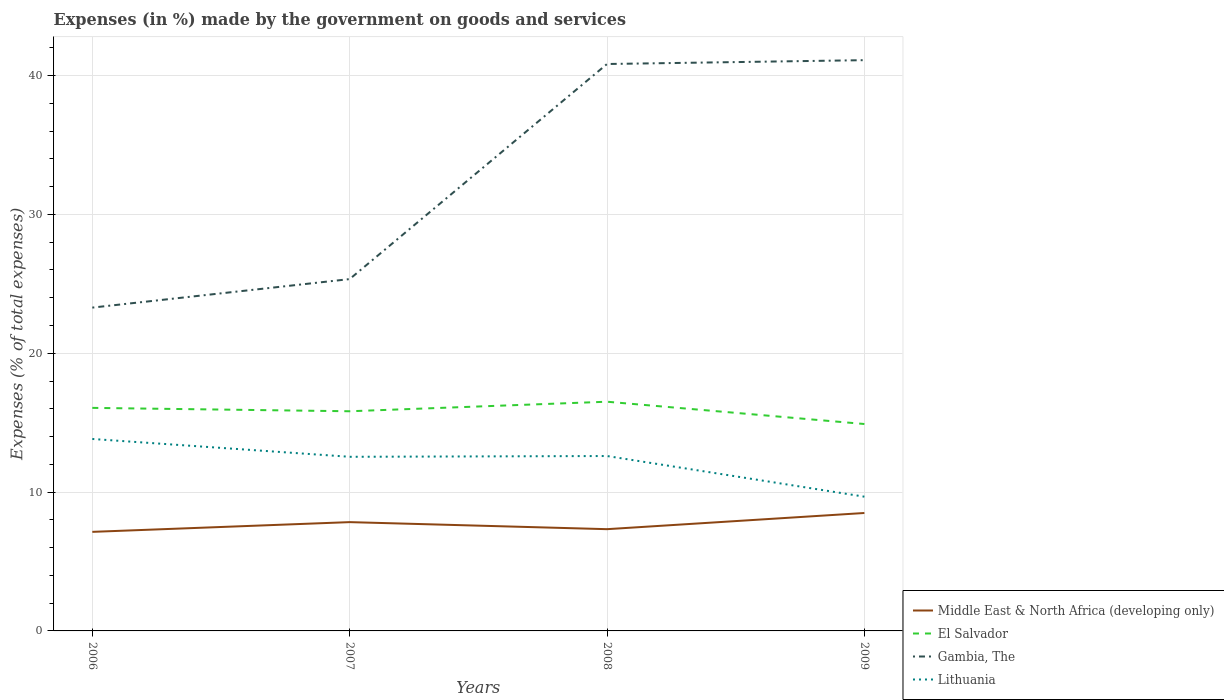How many different coloured lines are there?
Make the answer very short. 4. Is the number of lines equal to the number of legend labels?
Provide a succinct answer. Yes. Across all years, what is the maximum percentage of expenses made by the government on goods and services in Gambia, The?
Keep it short and to the point. 23.29. In which year was the percentage of expenses made by the government on goods and services in Middle East & North Africa (developing only) maximum?
Your answer should be compact. 2006. What is the total percentage of expenses made by the government on goods and services in El Salvador in the graph?
Provide a short and direct response. -0.44. What is the difference between the highest and the second highest percentage of expenses made by the government on goods and services in El Salvador?
Ensure brevity in your answer.  1.61. Is the percentage of expenses made by the government on goods and services in Gambia, The strictly greater than the percentage of expenses made by the government on goods and services in El Salvador over the years?
Provide a succinct answer. No. How many lines are there?
Your response must be concise. 4. How many years are there in the graph?
Your answer should be compact. 4. Are the values on the major ticks of Y-axis written in scientific E-notation?
Offer a very short reply. No. What is the title of the graph?
Your answer should be very brief. Expenses (in %) made by the government on goods and services. Does "High income: nonOECD" appear as one of the legend labels in the graph?
Your answer should be very brief. No. What is the label or title of the X-axis?
Give a very brief answer. Years. What is the label or title of the Y-axis?
Make the answer very short. Expenses (% of total expenses). What is the Expenses (% of total expenses) in Middle East & North Africa (developing only) in 2006?
Keep it short and to the point. 7.13. What is the Expenses (% of total expenses) in El Salvador in 2006?
Make the answer very short. 16.07. What is the Expenses (% of total expenses) in Gambia, The in 2006?
Offer a very short reply. 23.29. What is the Expenses (% of total expenses) in Lithuania in 2006?
Ensure brevity in your answer.  13.83. What is the Expenses (% of total expenses) of Middle East & North Africa (developing only) in 2007?
Provide a succinct answer. 7.84. What is the Expenses (% of total expenses) in El Salvador in 2007?
Offer a terse response. 15.82. What is the Expenses (% of total expenses) in Gambia, The in 2007?
Your answer should be very brief. 25.34. What is the Expenses (% of total expenses) of Lithuania in 2007?
Your answer should be compact. 12.54. What is the Expenses (% of total expenses) of Middle East & North Africa (developing only) in 2008?
Keep it short and to the point. 7.33. What is the Expenses (% of total expenses) in El Salvador in 2008?
Provide a short and direct response. 16.51. What is the Expenses (% of total expenses) of Gambia, The in 2008?
Your response must be concise. 40.83. What is the Expenses (% of total expenses) of Lithuania in 2008?
Provide a short and direct response. 12.6. What is the Expenses (% of total expenses) in Middle East & North Africa (developing only) in 2009?
Provide a succinct answer. 8.49. What is the Expenses (% of total expenses) of El Salvador in 2009?
Your answer should be very brief. 14.9. What is the Expenses (% of total expenses) in Gambia, The in 2009?
Provide a succinct answer. 41.11. What is the Expenses (% of total expenses) in Lithuania in 2009?
Your answer should be very brief. 9.67. Across all years, what is the maximum Expenses (% of total expenses) of Middle East & North Africa (developing only)?
Your answer should be very brief. 8.49. Across all years, what is the maximum Expenses (% of total expenses) of El Salvador?
Offer a very short reply. 16.51. Across all years, what is the maximum Expenses (% of total expenses) in Gambia, The?
Your answer should be very brief. 41.11. Across all years, what is the maximum Expenses (% of total expenses) of Lithuania?
Provide a short and direct response. 13.83. Across all years, what is the minimum Expenses (% of total expenses) in Middle East & North Africa (developing only)?
Offer a terse response. 7.13. Across all years, what is the minimum Expenses (% of total expenses) of El Salvador?
Provide a short and direct response. 14.9. Across all years, what is the minimum Expenses (% of total expenses) in Gambia, The?
Your answer should be compact. 23.29. Across all years, what is the minimum Expenses (% of total expenses) of Lithuania?
Give a very brief answer. 9.67. What is the total Expenses (% of total expenses) in Middle East & North Africa (developing only) in the graph?
Your answer should be compact. 30.79. What is the total Expenses (% of total expenses) in El Salvador in the graph?
Make the answer very short. 63.3. What is the total Expenses (% of total expenses) in Gambia, The in the graph?
Provide a short and direct response. 130.57. What is the total Expenses (% of total expenses) in Lithuania in the graph?
Provide a short and direct response. 48.63. What is the difference between the Expenses (% of total expenses) of Middle East & North Africa (developing only) in 2006 and that in 2007?
Give a very brief answer. -0.7. What is the difference between the Expenses (% of total expenses) of El Salvador in 2006 and that in 2007?
Make the answer very short. 0.24. What is the difference between the Expenses (% of total expenses) in Gambia, The in 2006 and that in 2007?
Provide a short and direct response. -2.05. What is the difference between the Expenses (% of total expenses) in Lithuania in 2006 and that in 2007?
Offer a very short reply. 1.28. What is the difference between the Expenses (% of total expenses) of Middle East & North Africa (developing only) in 2006 and that in 2008?
Provide a short and direct response. -0.19. What is the difference between the Expenses (% of total expenses) in El Salvador in 2006 and that in 2008?
Keep it short and to the point. -0.44. What is the difference between the Expenses (% of total expenses) of Gambia, The in 2006 and that in 2008?
Provide a succinct answer. -17.55. What is the difference between the Expenses (% of total expenses) in Lithuania in 2006 and that in 2008?
Your answer should be compact. 1.23. What is the difference between the Expenses (% of total expenses) in Middle East & North Africa (developing only) in 2006 and that in 2009?
Provide a succinct answer. -1.36. What is the difference between the Expenses (% of total expenses) of El Salvador in 2006 and that in 2009?
Give a very brief answer. 1.16. What is the difference between the Expenses (% of total expenses) in Gambia, The in 2006 and that in 2009?
Provide a succinct answer. -17.82. What is the difference between the Expenses (% of total expenses) in Lithuania in 2006 and that in 2009?
Ensure brevity in your answer.  4.16. What is the difference between the Expenses (% of total expenses) of Middle East & North Africa (developing only) in 2007 and that in 2008?
Your response must be concise. 0.51. What is the difference between the Expenses (% of total expenses) in El Salvador in 2007 and that in 2008?
Your response must be concise. -0.69. What is the difference between the Expenses (% of total expenses) of Gambia, The in 2007 and that in 2008?
Provide a short and direct response. -15.49. What is the difference between the Expenses (% of total expenses) of Lithuania in 2007 and that in 2008?
Provide a succinct answer. -0.06. What is the difference between the Expenses (% of total expenses) in Middle East & North Africa (developing only) in 2007 and that in 2009?
Keep it short and to the point. -0.66. What is the difference between the Expenses (% of total expenses) in El Salvador in 2007 and that in 2009?
Give a very brief answer. 0.92. What is the difference between the Expenses (% of total expenses) of Gambia, The in 2007 and that in 2009?
Keep it short and to the point. -15.77. What is the difference between the Expenses (% of total expenses) of Lithuania in 2007 and that in 2009?
Provide a succinct answer. 2.87. What is the difference between the Expenses (% of total expenses) in Middle East & North Africa (developing only) in 2008 and that in 2009?
Offer a terse response. -1.17. What is the difference between the Expenses (% of total expenses) of El Salvador in 2008 and that in 2009?
Provide a succinct answer. 1.61. What is the difference between the Expenses (% of total expenses) of Gambia, The in 2008 and that in 2009?
Make the answer very short. -0.28. What is the difference between the Expenses (% of total expenses) of Lithuania in 2008 and that in 2009?
Ensure brevity in your answer.  2.93. What is the difference between the Expenses (% of total expenses) in Middle East & North Africa (developing only) in 2006 and the Expenses (% of total expenses) in El Salvador in 2007?
Your answer should be very brief. -8.69. What is the difference between the Expenses (% of total expenses) in Middle East & North Africa (developing only) in 2006 and the Expenses (% of total expenses) in Gambia, The in 2007?
Ensure brevity in your answer.  -18.21. What is the difference between the Expenses (% of total expenses) of Middle East & North Africa (developing only) in 2006 and the Expenses (% of total expenses) of Lithuania in 2007?
Provide a succinct answer. -5.41. What is the difference between the Expenses (% of total expenses) in El Salvador in 2006 and the Expenses (% of total expenses) in Gambia, The in 2007?
Your answer should be very brief. -9.28. What is the difference between the Expenses (% of total expenses) in El Salvador in 2006 and the Expenses (% of total expenses) in Lithuania in 2007?
Your answer should be compact. 3.52. What is the difference between the Expenses (% of total expenses) of Gambia, The in 2006 and the Expenses (% of total expenses) of Lithuania in 2007?
Your response must be concise. 10.75. What is the difference between the Expenses (% of total expenses) in Middle East & North Africa (developing only) in 2006 and the Expenses (% of total expenses) in El Salvador in 2008?
Your answer should be very brief. -9.37. What is the difference between the Expenses (% of total expenses) in Middle East & North Africa (developing only) in 2006 and the Expenses (% of total expenses) in Gambia, The in 2008?
Give a very brief answer. -33.7. What is the difference between the Expenses (% of total expenses) of Middle East & North Africa (developing only) in 2006 and the Expenses (% of total expenses) of Lithuania in 2008?
Your answer should be very brief. -5.46. What is the difference between the Expenses (% of total expenses) in El Salvador in 2006 and the Expenses (% of total expenses) in Gambia, The in 2008?
Make the answer very short. -24.77. What is the difference between the Expenses (% of total expenses) in El Salvador in 2006 and the Expenses (% of total expenses) in Lithuania in 2008?
Make the answer very short. 3.47. What is the difference between the Expenses (% of total expenses) in Gambia, The in 2006 and the Expenses (% of total expenses) in Lithuania in 2008?
Provide a succinct answer. 10.69. What is the difference between the Expenses (% of total expenses) in Middle East & North Africa (developing only) in 2006 and the Expenses (% of total expenses) in El Salvador in 2009?
Your answer should be very brief. -7.77. What is the difference between the Expenses (% of total expenses) in Middle East & North Africa (developing only) in 2006 and the Expenses (% of total expenses) in Gambia, The in 2009?
Keep it short and to the point. -33.98. What is the difference between the Expenses (% of total expenses) in Middle East & North Africa (developing only) in 2006 and the Expenses (% of total expenses) in Lithuania in 2009?
Provide a short and direct response. -2.53. What is the difference between the Expenses (% of total expenses) in El Salvador in 2006 and the Expenses (% of total expenses) in Gambia, The in 2009?
Offer a very short reply. -25.05. What is the difference between the Expenses (% of total expenses) of El Salvador in 2006 and the Expenses (% of total expenses) of Lithuania in 2009?
Your answer should be very brief. 6.4. What is the difference between the Expenses (% of total expenses) in Gambia, The in 2006 and the Expenses (% of total expenses) in Lithuania in 2009?
Offer a terse response. 13.62. What is the difference between the Expenses (% of total expenses) in Middle East & North Africa (developing only) in 2007 and the Expenses (% of total expenses) in El Salvador in 2008?
Ensure brevity in your answer.  -8.67. What is the difference between the Expenses (% of total expenses) in Middle East & North Africa (developing only) in 2007 and the Expenses (% of total expenses) in Gambia, The in 2008?
Provide a short and direct response. -33. What is the difference between the Expenses (% of total expenses) in Middle East & North Africa (developing only) in 2007 and the Expenses (% of total expenses) in Lithuania in 2008?
Offer a terse response. -4.76. What is the difference between the Expenses (% of total expenses) in El Salvador in 2007 and the Expenses (% of total expenses) in Gambia, The in 2008?
Your answer should be very brief. -25.01. What is the difference between the Expenses (% of total expenses) of El Salvador in 2007 and the Expenses (% of total expenses) of Lithuania in 2008?
Ensure brevity in your answer.  3.22. What is the difference between the Expenses (% of total expenses) in Gambia, The in 2007 and the Expenses (% of total expenses) in Lithuania in 2008?
Give a very brief answer. 12.74. What is the difference between the Expenses (% of total expenses) of Middle East & North Africa (developing only) in 2007 and the Expenses (% of total expenses) of El Salvador in 2009?
Offer a very short reply. -7.07. What is the difference between the Expenses (% of total expenses) in Middle East & North Africa (developing only) in 2007 and the Expenses (% of total expenses) in Gambia, The in 2009?
Your answer should be compact. -33.27. What is the difference between the Expenses (% of total expenses) in Middle East & North Africa (developing only) in 2007 and the Expenses (% of total expenses) in Lithuania in 2009?
Your answer should be compact. -1.83. What is the difference between the Expenses (% of total expenses) of El Salvador in 2007 and the Expenses (% of total expenses) of Gambia, The in 2009?
Make the answer very short. -25.29. What is the difference between the Expenses (% of total expenses) in El Salvador in 2007 and the Expenses (% of total expenses) in Lithuania in 2009?
Make the answer very short. 6.15. What is the difference between the Expenses (% of total expenses) in Gambia, The in 2007 and the Expenses (% of total expenses) in Lithuania in 2009?
Offer a very short reply. 15.67. What is the difference between the Expenses (% of total expenses) of Middle East & North Africa (developing only) in 2008 and the Expenses (% of total expenses) of El Salvador in 2009?
Make the answer very short. -7.57. What is the difference between the Expenses (% of total expenses) of Middle East & North Africa (developing only) in 2008 and the Expenses (% of total expenses) of Gambia, The in 2009?
Offer a terse response. -33.78. What is the difference between the Expenses (% of total expenses) in Middle East & North Africa (developing only) in 2008 and the Expenses (% of total expenses) in Lithuania in 2009?
Your answer should be compact. -2.34. What is the difference between the Expenses (% of total expenses) in El Salvador in 2008 and the Expenses (% of total expenses) in Gambia, The in 2009?
Provide a short and direct response. -24.6. What is the difference between the Expenses (% of total expenses) of El Salvador in 2008 and the Expenses (% of total expenses) of Lithuania in 2009?
Offer a very short reply. 6.84. What is the difference between the Expenses (% of total expenses) in Gambia, The in 2008 and the Expenses (% of total expenses) in Lithuania in 2009?
Provide a succinct answer. 31.16. What is the average Expenses (% of total expenses) in Middle East & North Africa (developing only) per year?
Provide a succinct answer. 7.7. What is the average Expenses (% of total expenses) of El Salvador per year?
Make the answer very short. 15.82. What is the average Expenses (% of total expenses) in Gambia, The per year?
Give a very brief answer. 32.64. What is the average Expenses (% of total expenses) in Lithuania per year?
Offer a terse response. 12.16. In the year 2006, what is the difference between the Expenses (% of total expenses) of Middle East & North Africa (developing only) and Expenses (% of total expenses) of El Salvador?
Keep it short and to the point. -8.93. In the year 2006, what is the difference between the Expenses (% of total expenses) in Middle East & North Africa (developing only) and Expenses (% of total expenses) in Gambia, The?
Keep it short and to the point. -16.15. In the year 2006, what is the difference between the Expenses (% of total expenses) in Middle East & North Africa (developing only) and Expenses (% of total expenses) in Lithuania?
Keep it short and to the point. -6.69. In the year 2006, what is the difference between the Expenses (% of total expenses) of El Salvador and Expenses (% of total expenses) of Gambia, The?
Make the answer very short. -7.22. In the year 2006, what is the difference between the Expenses (% of total expenses) in El Salvador and Expenses (% of total expenses) in Lithuania?
Give a very brief answer. 2.24. In the year 2006, what is the difference between the Expenses (% of total expenses) in Gambia, The and Expenses (% of total expenses) in Lithuania?
Offer a very short reply. 9.46. In the year 2007, what is the difference between the Expenses (% of total expenses) of Middle East & North Africa (developing only) and Expenses (% of total expenses) of El Salvador?
Give a very brief answer. -7.99. In the year 2007, what is the difference between the Expenses (% of total expenses) in Middle East & North Africa (developing only) and Expenses (% of total expenses) in Gambia, The?
Provide a short and direct response. -17.51. In the year 2007, what is the difference between the Expenses (% of total expenses) of Middle East & North Africa (developing only) and Expenses (% of total expenses) of Lithuania?
Offer a terse response. -4.71. In the year 2007, what is the difference between the Expenses (% of total expenses) in El Salvador and Expenses (% of total expenses) in Gambia, The?
Your response must be concise. -9.52. In the year 2007, what is the difference between the Expenses (% of total expenses) of El Salvador and Expenses (% of total expenses) of Lithuania?
Offer a terse response. 3.28. In the year 2007, what is the difference between the Expenses (% of total expenses) of Gambia, The and Expenses (% of total expenses) of Lithuania?
Your answer should be compact. 12.8. In the year 2008, what is the difference between the Expenses (% of total expenses) in Middle East & North Africa (developing only) and Expenses (% of total expenses) in El Salvador?
Provide a succinct answer. -9.18. In the year 2008, what is the difference between the Expenses (% of total expenses) of Middle East & North Africa (developing only) and Expenses (% of total expenses) of Gambia, The?
Offer a very short reply. -33.5. In the year 2008, what is the difference between the Expenses (% of total expenses) of Middle East & North Africa (developing only) and Expenses (% of total expenses) of Lithuania?
Keep it short and to the point. -5.27. In the year 2008, what is the difference between the Expenses (% of total expenses) of El Salvador and Expenses (% of total expenses) of Gambia, The?
Keep it short and to the point. -24.32. In the year 2008, what is the difference between the Expenses (% of total expenses) in El Salvador and Expenses (% of total expenses) in Lithuania?
Provide a succinct answer. 3.91. In the year 2008, what is the difference between the Expenses (% of total expenses) of Gambia, The and Expenses (% of total expenses) of Lithuania?
Provide a short and direct response. 28.24. In the year 2009, what is the difference between the Expenses (% of total expenses) of Middle East & North Africa (developing only) and Expenses (% of total expenses) of El Salvador?
Make the answer very short. -6.41. In the year 2009, what is the difference between the Expenses (% of total expenses) of Middle East & North Africa (developing only) and Expenses (% of total expenses) of Gambia, The?
Provide a succinct answer. -32.62. In the year 2009, what is the difference between the Expenses (% of total expenses) of Middle East & North Africa (developing only) and Expenses (% of total expenses) of Lithuania?
Give a very brief answer. -1.17. In the year 2009, what is the difference between the Expenses (% of total expenses) in El Salvador and Expenses (% of total expenses) in Gambia, The?
Make the answer very short. -26.21. In the year 2009, what is the difference between the Expenses (% of total expenses) in El Salvador and Expenses (% of total expenses) in Lithuania?
Provide a short and direct response. 5.23. In the year 2009, what is the difference between the Expenses (% of total expenses) in Gambia, The and Expenses (% of total expenses) in Lithuania?
Your response must be concise. 31.44. What is the ratio of the Expenses (% of total expenses) in Middle East & North Africa (developing only) in 2006 to that in 2007?
Your answer should be very brief. 0.91. What is the ratio of the Expenses (% of total expenses) in El Salvador in 2006 to that in 2007?
Offer a terse response. 1.02. What is the ratio of the Expenses (% of total expenses) in Gambia, The in 2006 to that in 2007?
Your answer should be very brief. 0.92. What is the ratio of the Expenses (% of total expenses) in Lithuania in 2006 to that in 2007?
Your answer should be very brief. 1.1. What is the ratio of the Expenses (% of total expenses) of Middle East & North Africa (developing only) in 2006 to that in 2008?
Offer a terse response. 0.97. What is the ratio of the Expenses (% of total expenses) of El Salvador in 2006 to that in 2008?
Your answer should be compact. 0.97. What is the ratio of the Expenses (% of total expenses) of Gambia, The in 2006 to that in 2008?
Provide a short and direct response. 0.57. What is the ratio of the Expenses (% of total expenses) of Lithuania in 2006 to that in 2008?
Offer a terse response. 1.1. What is the ratio of the Expenses (% of total expenses) in Middle East & North Africa (developing only) in 2006 to that in 2009?
Provide a short and direct response. 0.84. What is the ratio of the Expenses (% of total expenses) in El Salvador in 2006 to that in 2009?
Offer a terse response. 1.08. What is the ratio of the Expenses (% of total expenses) of Gambia, The in 2006 to that in 2009?
Provide a succinct answer. 0.57. What is the ratio of the Expenses (% of total expenses) in Lithuania in 2006 to that in 2009?
Provide a short and direct response. 1.43. What is the ratio of the Expenses (% of total expenses) in Middle East & North Africa (developing only) in 2007 to that in 2008?
Your response must be concise. 1.07. What is the ratio of the Expenses (% of total expenses) of El Salvador in 2007 to that in 2008?
Your answer should be very brief. 0.96. What is the ratio of the Expenses (% of total expenses) of Gambia, The in 2007 to that in 2008?
Your answer should be very brief. 0.62. What is the ratio of the Expenses (% of total expenses) in Middle East & North Africa (developing only) in 2007 to that in 2009?
Your answer should be very brief. 0.92. What is the ratio of the Expenses (% of total expenses) in El Salvador in 2007 to that in 2009?
Provide a succinct answer. 1.06. What is the ratio of the Expenses (% of total expenses) of Gambia, The in 2007 to that in 2009?
Provide a succinct answer. 0.62. What is the ratio of the Expenses (% of total expenses) of Lithuania in 2007 to that in 2009?
Your answer should be compact. 1.3. What is the ratio of the Expenses (% of total expenses) in Middle East & North Africa (developing only) in 2008 to that in 2009?
Your answer should be very brief. 0.86. What is the ratio of the Expenses (% of total expenses) of El Salvador in 2008 to that in 2009?
Your response must be concise. 1.11. What is the ratio of the Expenses (% of total expenses) of Gambia, The in 2008 to that in 2009?
Offer a very short reply. 0.99. What is the ratio of the Expenses (% of total expenses) of Lithuania in 2008 to that in 2009?
Make the answer very short. 1.3. What is the difference between the highest and the second highest Expenses (% of total expenses) of Middle East & North Africa (developing only)?
Ensure brevity in your answer.  0.66. What is the difference between the highest and the second highest Expenses (% of total expenses) of El Salvador?
Provide a short and direct response. 0.44. What is the difference between the highest and the second highest Expenses (% of total expenses) of Gambia, The?
Keep it short and to the point. 0.28. What is the difference between the highest and the second highest Expenses (% of total expenses) of Lithuania?
Offer a terse response. 1.23. What is the difference between the highest and the lowest Expenses (% of total expenses) in Middle East & North Africa (developing only)?
Provide a short and direct response. 1.36. What is the difference between the highest and the lowest Expenses (% of total expenses) in El Salvador?
Offer a very short reply. 1.61. What is the difference between the highest and the lowest Expenses (% of total expenses) in Gambia, The?
Offer a terse response. 17.82. What is the difference between the highest and the lowest Expenses (% of total expenses) of Lithuania?
Provide a short and direct response. 4.16. 